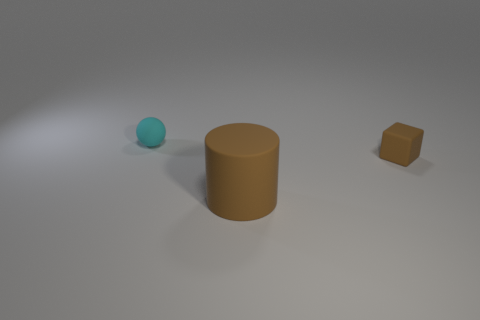Subtract all blue cylinders. Subtract all cyan balls. How many cylinders are left? 1 Add 1 things. How many objects exist? 4 Subtract all balls. How many objects are left? 2 Subtract all large objects. Subtract all big objects. How many objects are left? 1 Add 1 tiny brown blocks. How many tiny brown blocks are left? 2 Add 3 brown cubes. How many brown cubes exist? 4 Subtract 0 yellow cylinders. How many objects are left? 3 